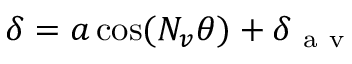<formula> <loc_0><loc_0><loc_500><loc_500>\delta = a \cos ( N _ { v } \theta ) + \delta _ { a v }</formula> 